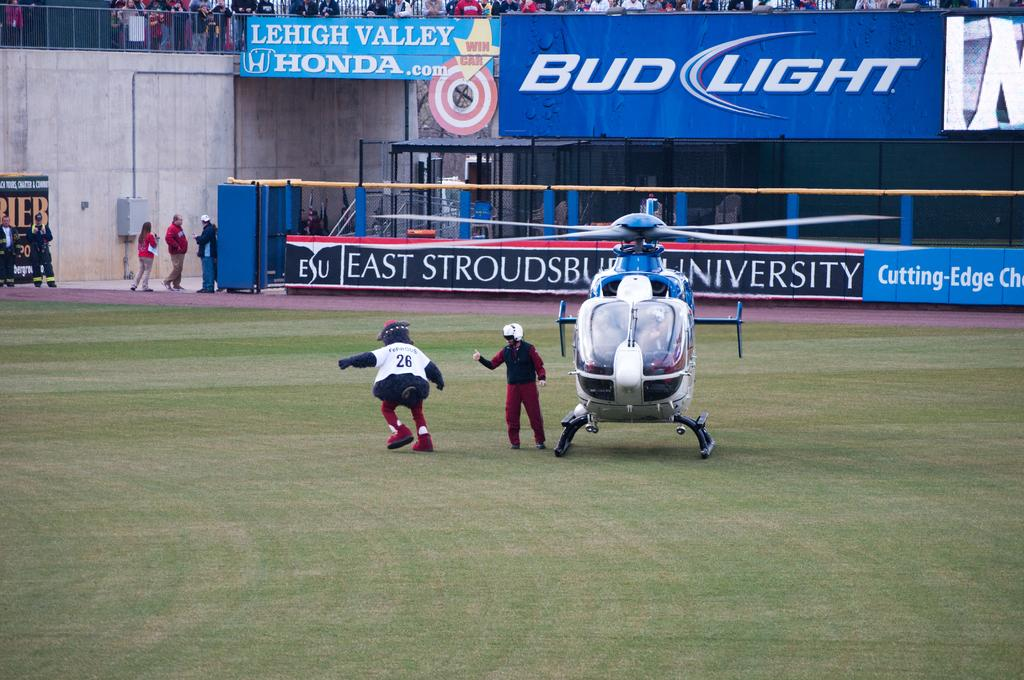What is the main subject in the center of the image? There is a helicopter in the center of the image. How many people are visible in the image? There are two people in the image. What can be seen in the background of the image? There are boards, a fence, a crowd, and a wall in the background of the image. Where are the people standing in the image? There are people standing on the left side of the image. What type of cherries are being sold by the people standing on the left side of the image? There are no cherries present in the image; the people are not selling any items. What crime is being committed by the helicopter in the image? There is no crime being committed by the helicopter in the image; it is simply a stationary subject in the center of the image. 